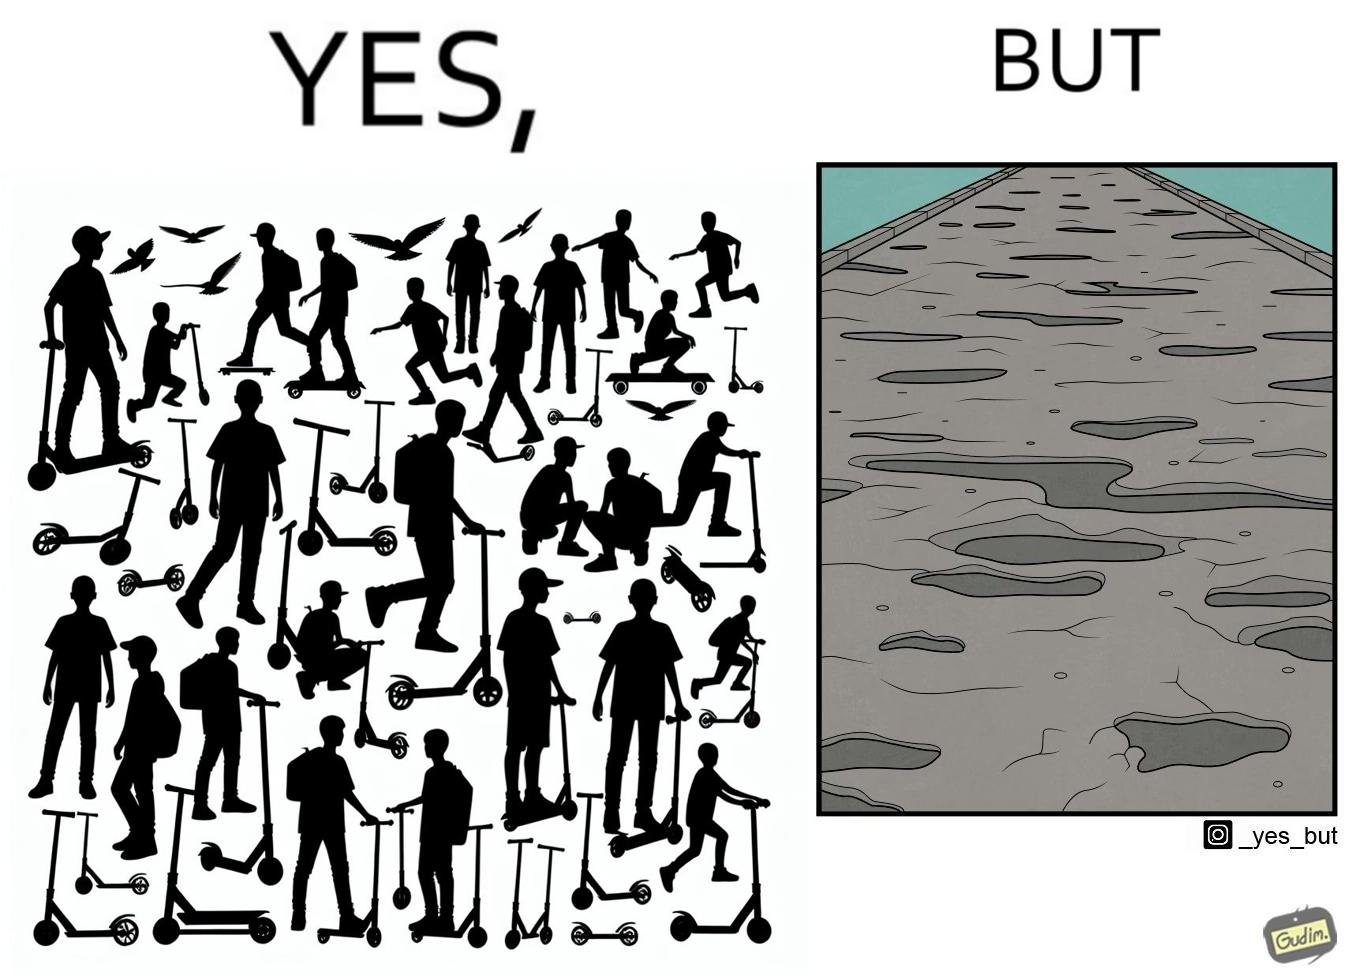What is the satirical meaning behind this image? The image is ironic, because even after when the skateboard scooters are available for someone to ride but the road has many potholes that it is not suitable to ride the scooters on such roads 